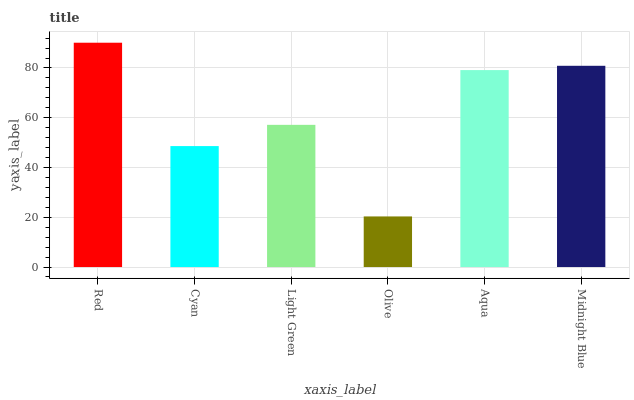Is Olive the minimum?
Answer yes or no. Yes. Is Red the maximum?
Answer yes or no. Yes. Is Cyan the minimum?
Answer yes or no. No. Is Cyan the maximum?
Answer yes or no. No. Is Red greater than Cyan?
Answer yes or no. Yes. Is Cyan less than Red?
Answer yes or no. Yes. Is Cyan greater than Red?
Answer yes or no. No. Is Red less than Cyan?
Answer yes or no. No. Is Aqua the high median?
Answer yes or no. Yes. Is Light Green the low median?
Answer yes or no. Yes. Is Olive the high median?
Answer yes or no. No. Is Olive the low median?
Answer yes or no. No. 